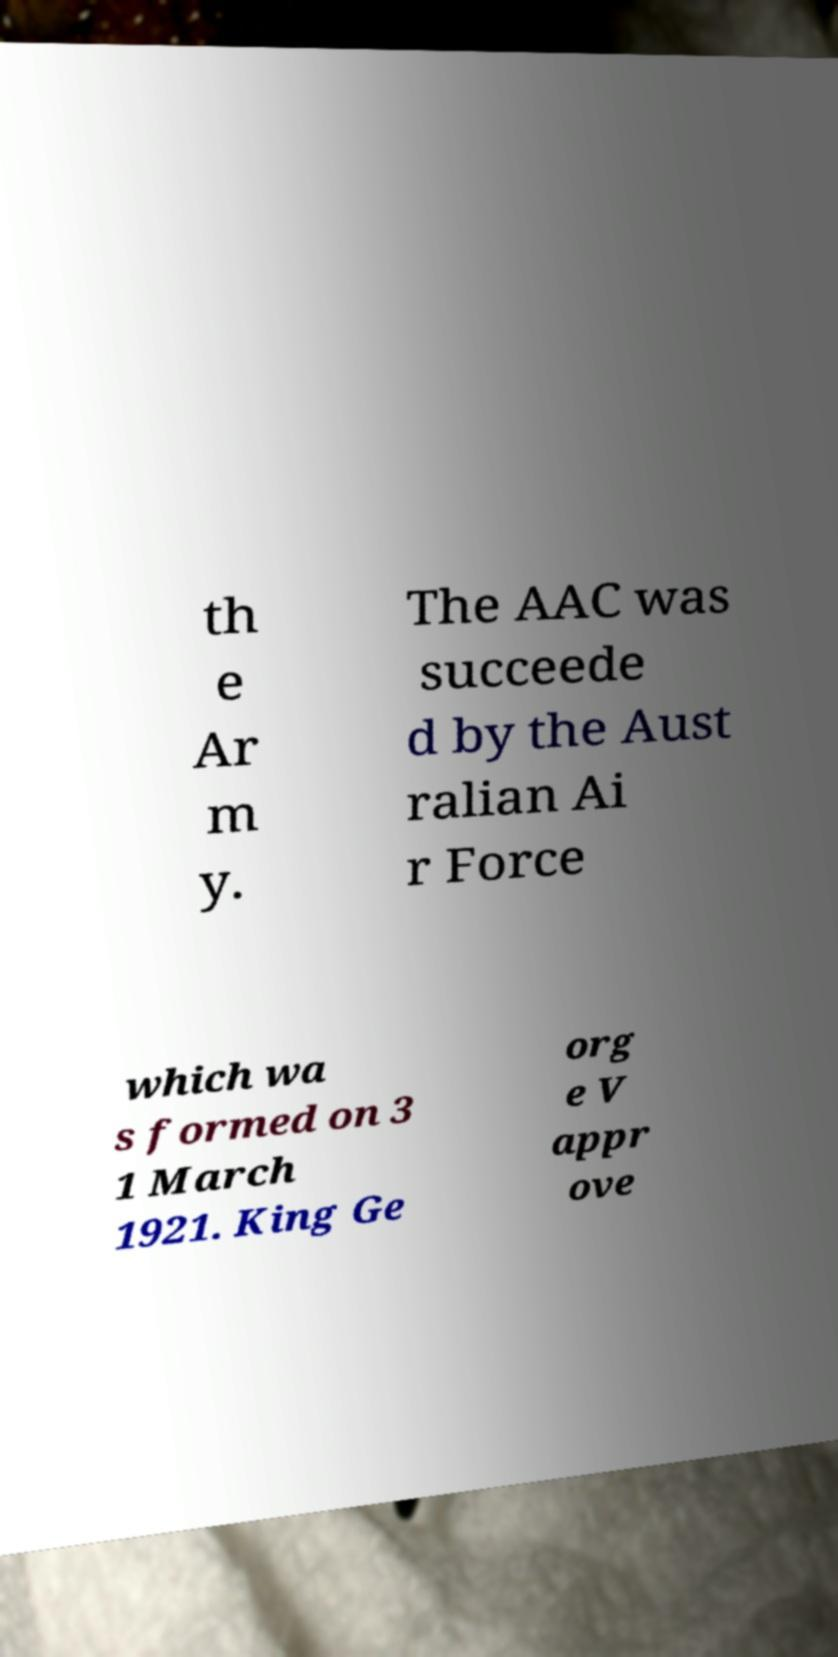Can you read and provide the text displayed in the image?This photo seems to have some interesting text. Can you extract and type it out for me? th e Ar m y. The AAC was succeede d by the Aust ralian Ai r Force which wa s formed on 3 1 March 1921. King Ge org e V appr ove 